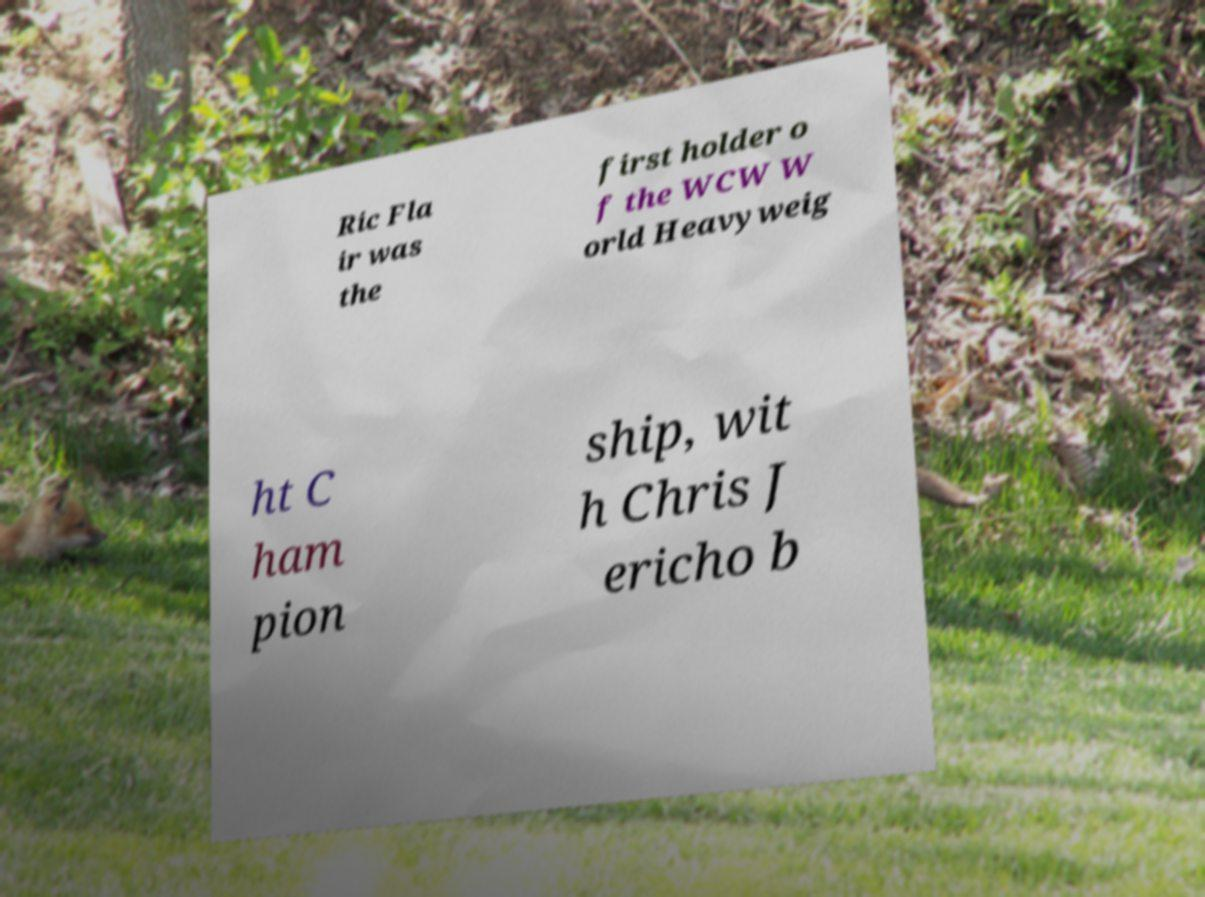For documentation purposes, I need the text within this image transcribed. Could you provide that? Ric Fla ir was the first holder o f the WCW W orld Heavyweig ht C ham pion ship, wit h Chris J ericho b 